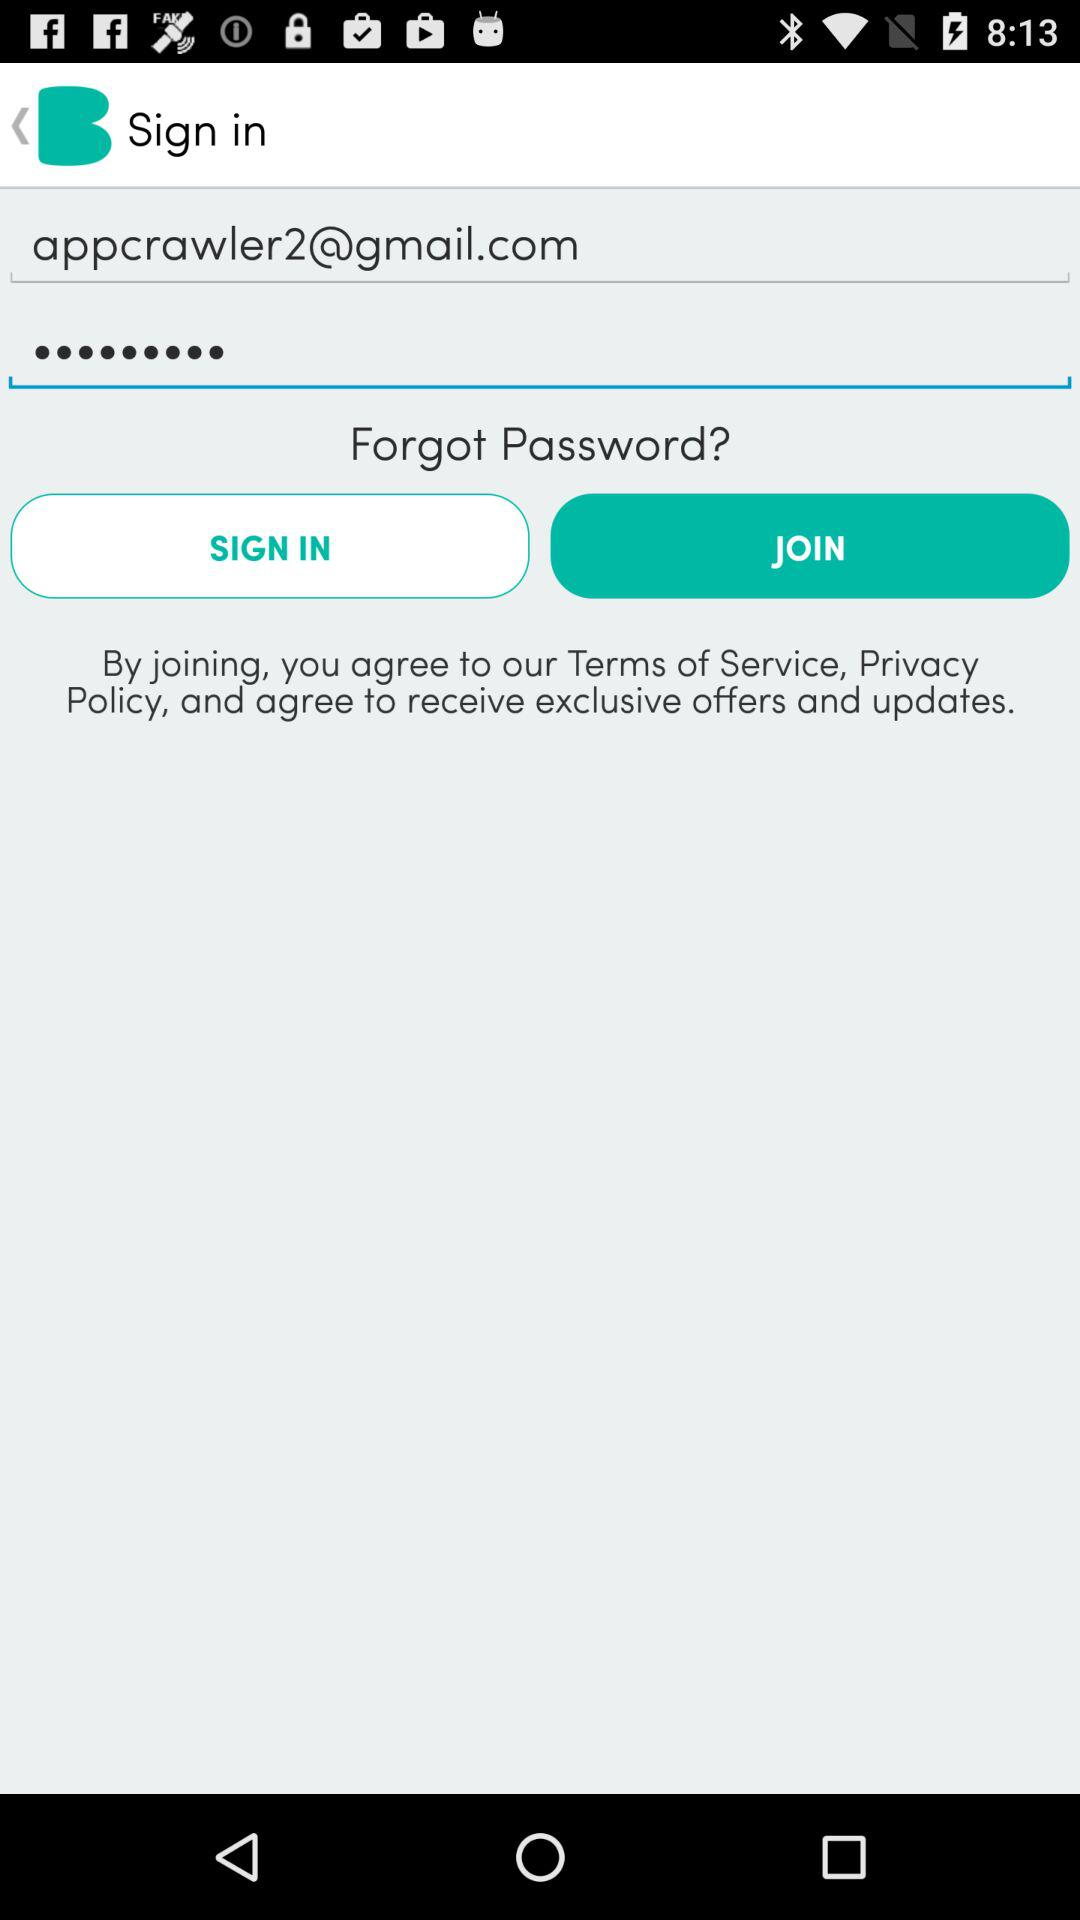What is the email address? The email address is "appcrawler2@gmail.com". 